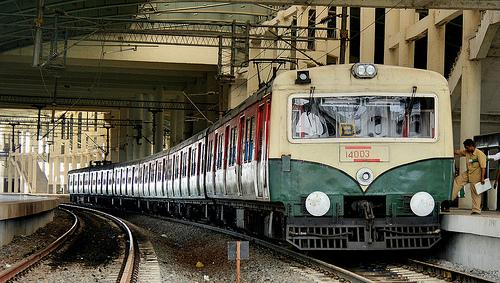Name the different colors present on the train in the image. The train has beige, red, green, and tan colors. What distinct color can be found on the front of the train? The front of the train is white and green. Can you spot any people in the image who are not wearing a uniform? Describe them. Yes, there is a man in yellow and another person wearing brown, possibly holding white papers. Is there any visible infrastructure surrounding the train in the image? If so, describe it. Yes, there seems to be a walkway above the train, black overhead metal beams, and a beige staircase with pillars in the distance. What type of train is depicted in the image? The image shows a passenger train. What type of sign can be found at the front of the train, and what does it display? There is an identification sign displaying the train's number, 14003, in red font. How many cars does the train in the image consist of, and what is its current status? The train has six cars, and it appears to be parked or stationary at the station. What is the train's identification number and provide the color of the font? The train's identification number is 14003, and the font color is red. While observing the picture, can you see a person wearing a uniform near the train? Describe them. Yes, there is a man in uniform, possibly a railroad worker or conductor, standing by the train. He is wearing a white shirt and a hat. What is the condition of the train's headlights? Are they turned on or off? The train's headlights are not on. 